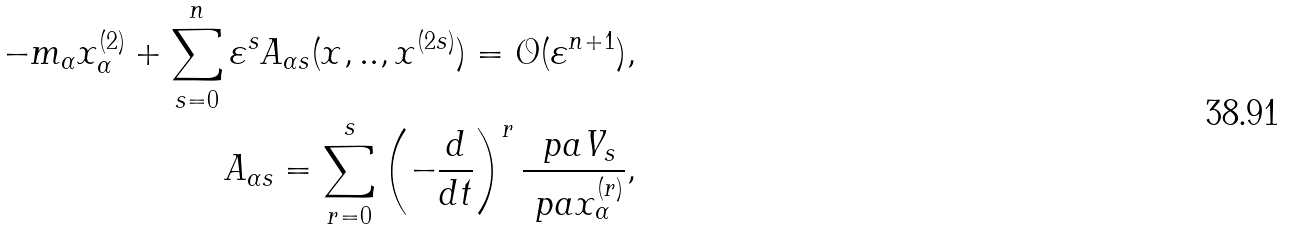<formula> <loc_0><loc_0><loc_500><loc_500>- m _ { \alpha } x _ { \alpha } ^ { ( 2 ) } + \sum _ { s = 0 } ^ { n } \varepsilon ^ { s } A _ { \alpha s } ( x , . . , x ^ { ( 2 s ) } ) = \mathcal { O } ( \varepsilon ^ { n + 1 } ) , \\ A _ { \alpha s } = \sum _ { r = 0 } ^ { s } \left ( - \frac { d } { d t } \right ) ^ { r } \frac { \ p a V _ { s } } { \ p a x _ { \alpha } ^ { ( r ) } } ,</formula> 